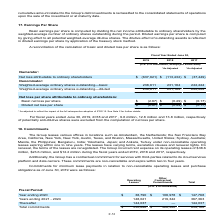From Atlassian Plc's financial document, What is the value of the incurred rent expense on the Group's operating leases during fiscal years ended 2017, 2018 and 2019 respectively?  The document contains multiple relevant values: $12.2 million, $23.6 million, $38.6 million. From the document: "rating leases of $38.6 million, $23.6 million, and $12.2 million during the fiscal years ended 2019, 2018 and 2017, respectively. p incurred rent expe..." Also, What are the total commitments towards operating leases? According to the financial document, $330,848 (in thousands). The relevant text states: "Total commitments $ 330,848 $ 328,320 659,168..." Also, What are the total commitments towards other contractual commitments? According to the financial document, $328,320 (in thousands). The relevant text states: "Total commitments $ 330,848 $ 328,320 659,168..." Also, What is the total number of countries that the Group leases offices in? Counting the relevant items in the document: the Netherlands, United States, Australia, Philippines, India, Japan, Turkey, I find 7 instances. The key data points involved are: Australia, India, Japan. Also, can you calculate: What is the difference in the total commitments between that of operating leases and other contractual commitments? Based on the calculation: 330,848-328,320, the result is 2528 (in thousands). This is based on the information: "Total commitments $ 330,848 $ 328,320 659,168 Total commitments $ 330,848 $ 328,320 659,168..." The key data points involved are: 328,320, 330,848. Also, can you calculate: What is the percentage constitution of the commitments for operating leases for year ending 2020 among the total commitments for operating leases? Based on the calculation: 38,790/330,848, the result is 11.72 (percentage). This is based on the information: "Total commitments $ 330,848 $ 328,320 659,168 Year ending 2020 $ 38,790 $ 108,978 $ 147,768..." The key data points involved are: 330,848, 38,790. 